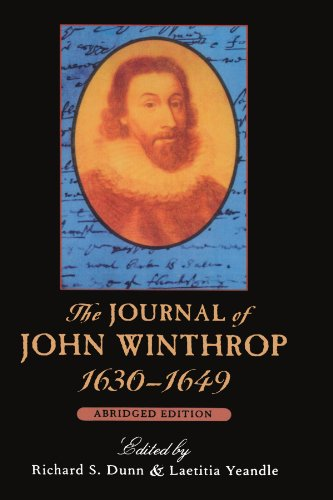What type of book is this? This is a historical biography, focusing on the personal and public life of John Winthrop during America's colonial period. 